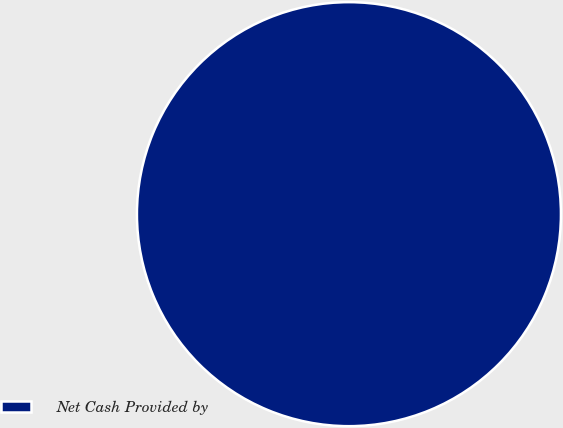<chart> <loc_0><loc_0><loc_500><loc_500><pie_chart><fcel>Net Cash Provided by<nl><fcel>100.0%<nl></chart> 